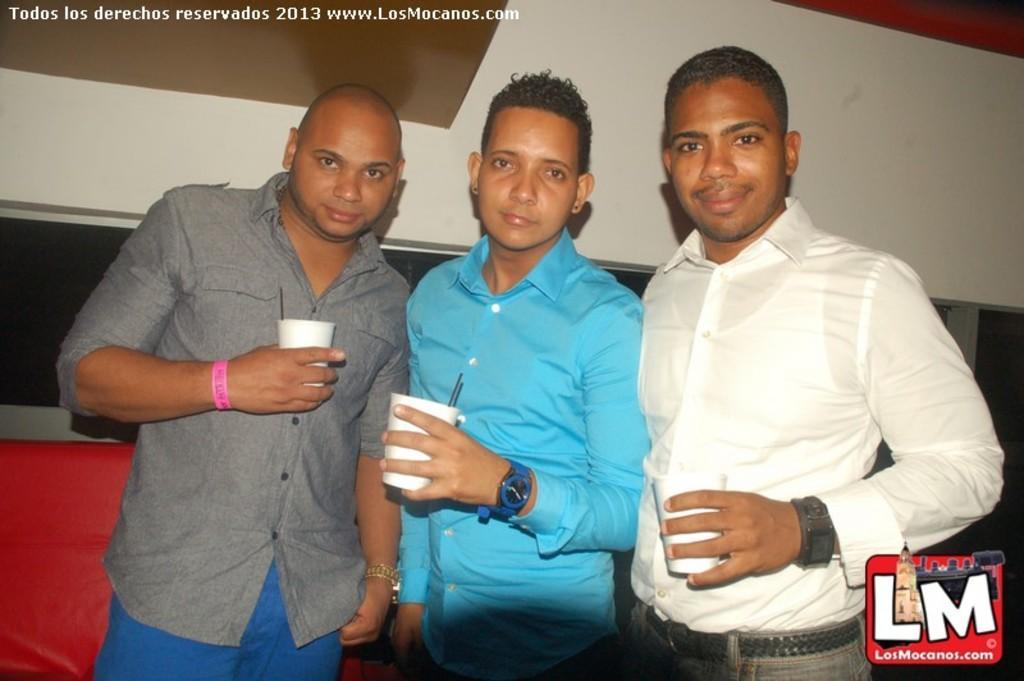Can you describe this image briefly? In this picture, we see three men are standing and they are posing for the photo. The man on the right side is smiling. On the left side, we see a red color sofa. In the background, we see a wall in white and black color. In the right bottom, we see a logo. 